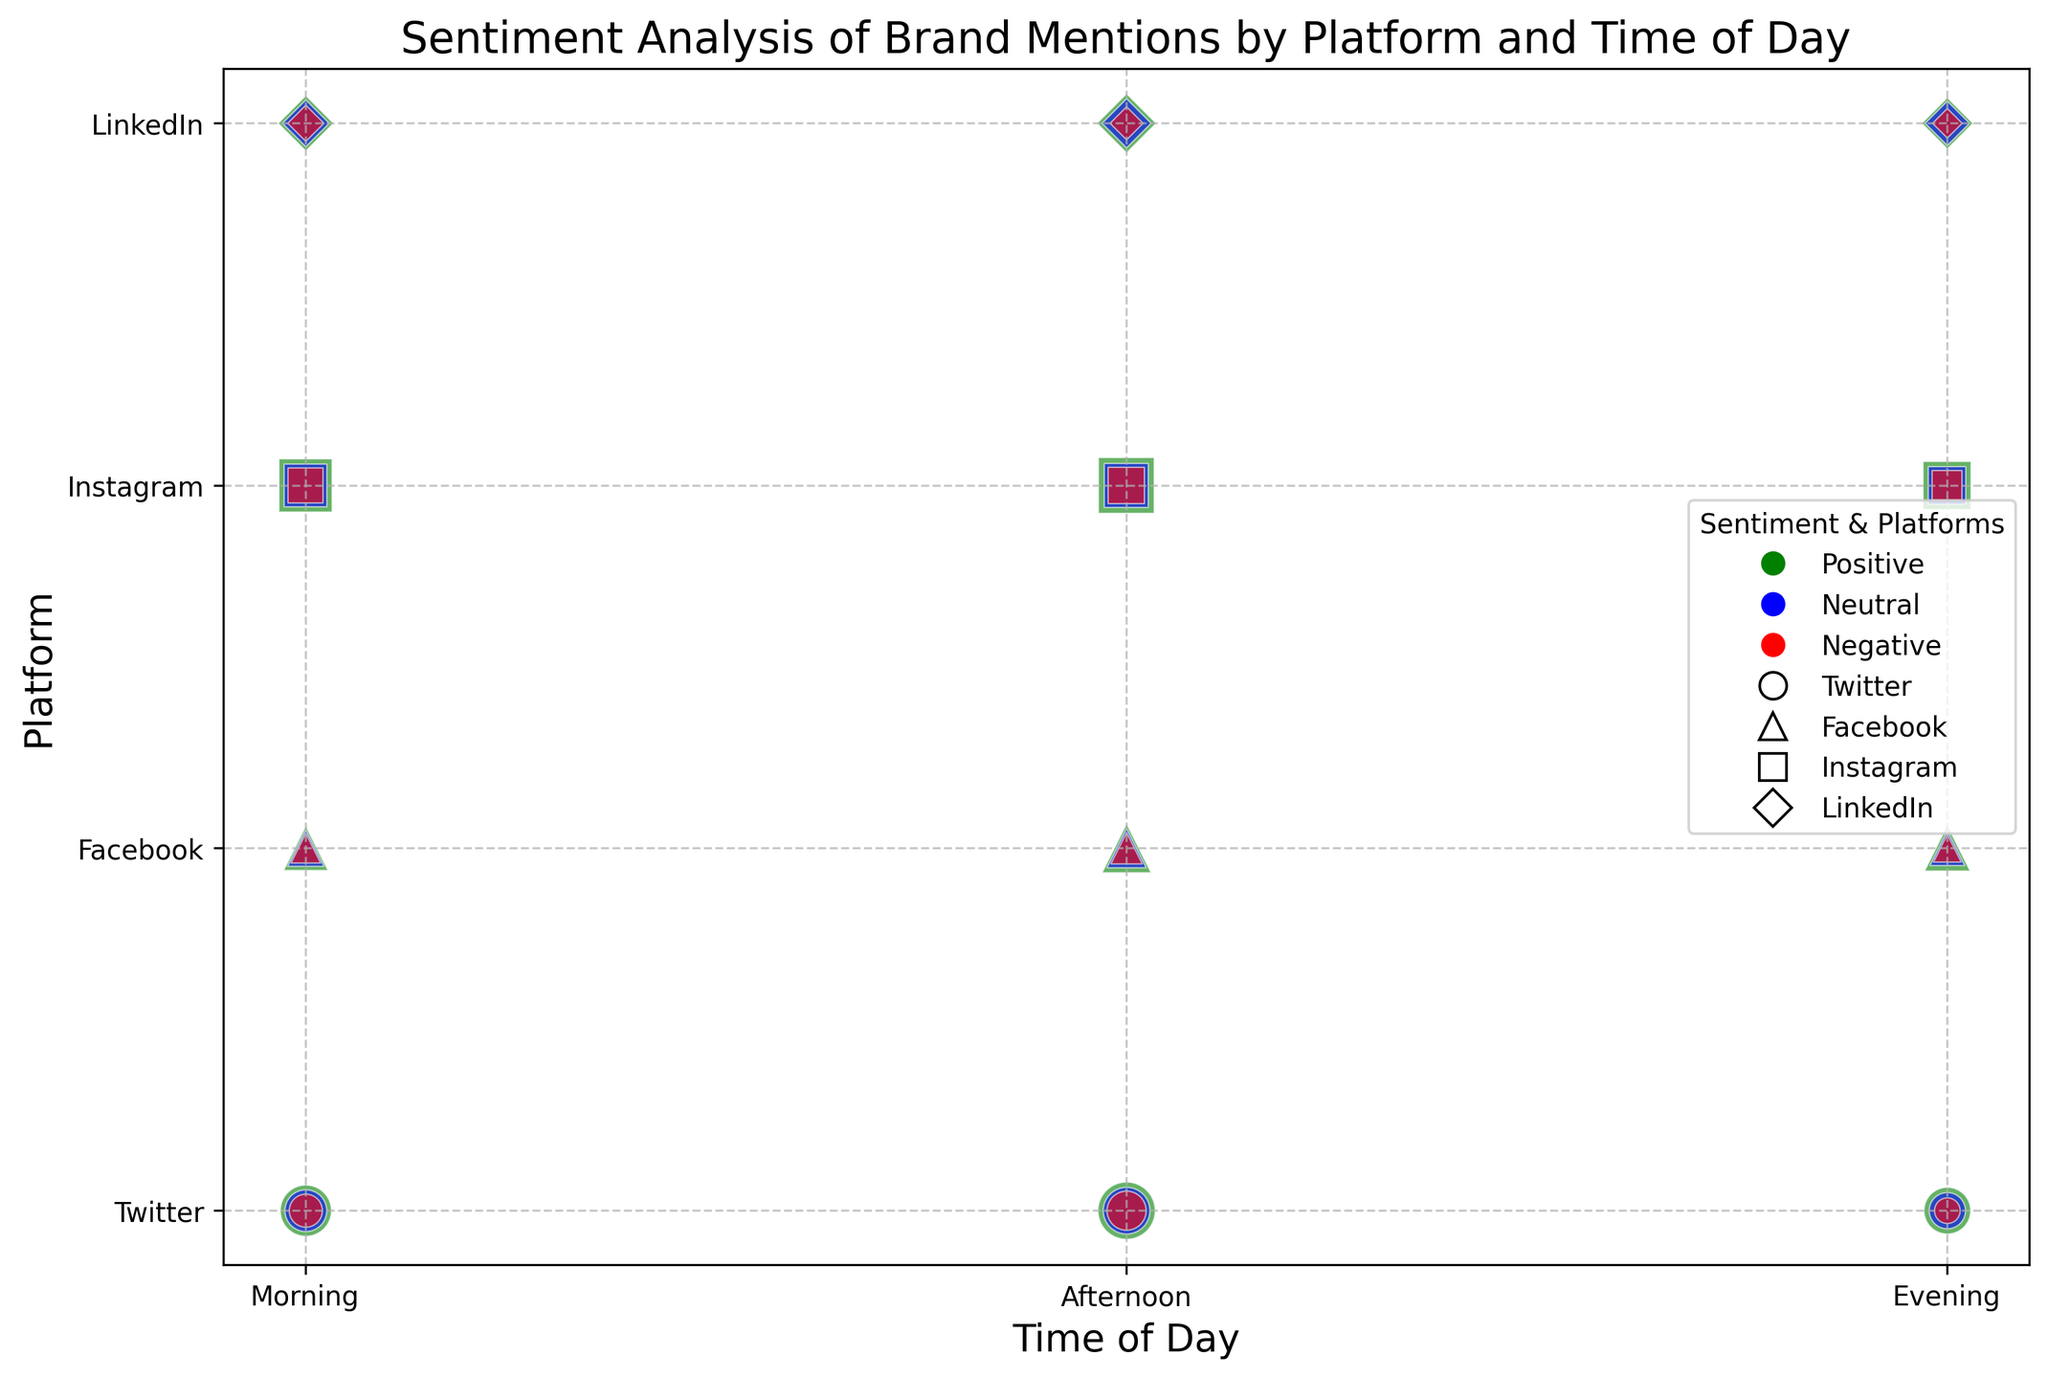Which platform has the highest volume of positive mentions in the morning? Look at the size of the bubbles for the 'Positive' sentiment during 'Morning' for each platform. The largest bubble represents the highest volume, which corresponds to Instagram.
Answer: Instagram Which platform has the least volume of negative mentions in the evening? Check the size of the bubbles for the 'Negative' sentiment during 'Evening' for all platforms. The smallest bubble is associated with LinkedIn.
Answer: LinkedIn Is there a larger volume of positive mentions on Instagram in the afternoon or on Twitter in the morning? Compare the size of the 'Positive' sentiment bubbles for Instagram in the afternoon and Twitter in the morning. The Instagram bubble in the afternoon is larger.
Answer: Instagram in the afternoon How does the volume of neutral mentions on Facebook in the evening compare to LinkedIn in the afternoon? Compare the size of the 'Neutral' sentiment bubbles for Facebook in the evening and LinkedIn in the afternoon. The bubble for Facebook is larger than LinkedIn's bubble.
Answer: Facebook is larger What is the difference in the volume of negative mentions between Twitter and Facebook in the afternoon? Check the size of the 'Negative' sentiment bubbles for both Twitter and Facebook in the afternoon. Twitter's bubble represents 70 and Facebook's is 45. The difference is 70 - 45 = 25.
Answer: 25 Which time of day has the highest volume of positive mentions across all platforms? Sum up the volumes of 'Positive' sentiment bubbles for each time of day across all platforms: Morning (120+90+130+70), Afternoon (150+110+140+80), Evening (100+95+105+60). Afternoon has the highest total volume.
Answer: Afternoon Are there more neutral mentions on Twitter or positive mentions on LinkedIn in the evening? Compare the size of the 'Neutral' sentiment bubble for Twitter and 'Positive' sentiment bubble for LinkedIn in the evening. Twitter's neutral mention bubble is larger.
Answer: Neutral mentions on Twitter Which platform has the most consistent volume of positive mentions throughout the day? Observe the size of 'Positive' sentiment bubbles throughout the day for each platform. Instagram has relatively consistent bubble sizes across Morning (130), Afternoon (140), and Evening (105).
Answer: Instagram Which platform and time of day combination has the smallest volume of neutral mentions? Find the smallest 'Neutral' sentiment bubble across all platforms and times of day. The smallest bubble corresponds to LinkedIn in the evening.
Answer: LinkedIn in the evening What is the sum of the volumes of negative mentions for LinkedIn throughout the day? Add the volumes of 'Negative' sentiment bubbles for LinkedIn in the Morning (30), Afternoon (25), and Evening (20): 30 + 25 + 20 = 75.
Answer: 75 